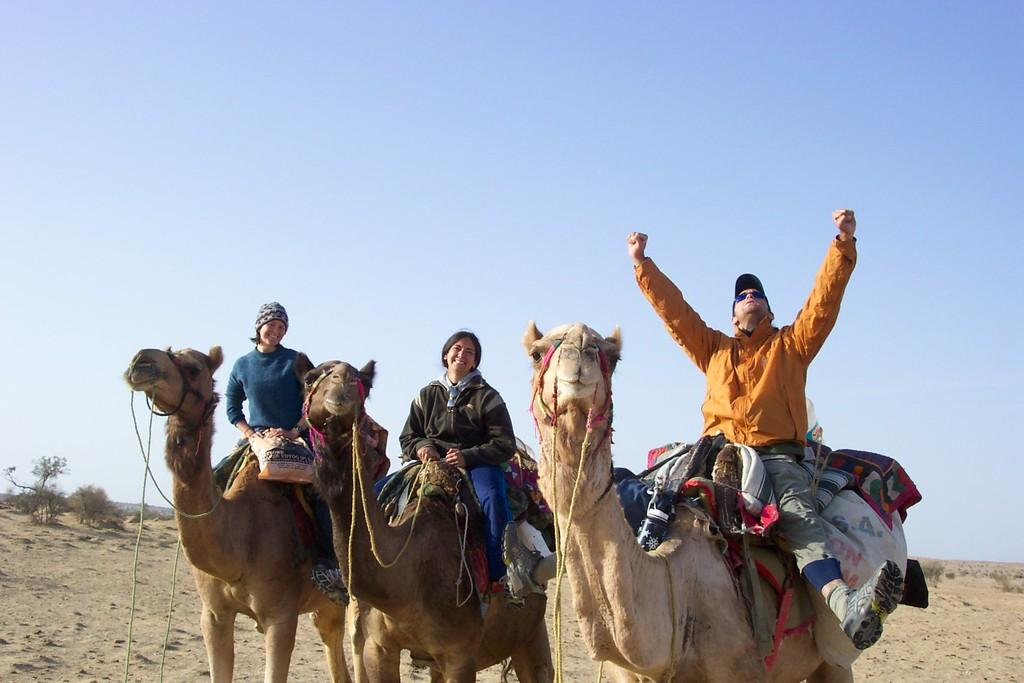What are the people in the image riding? The people in the image are sitting on camels. What can be seen in the background of the image? There are trees and the sky visible in the background of the image. What type of terrain is present at the bottom of the image? There is sand at the bottom of the image. How much patch is visible on the camels in the image? There is no mention of patch on the camels in the image, so it cannot be determined. 